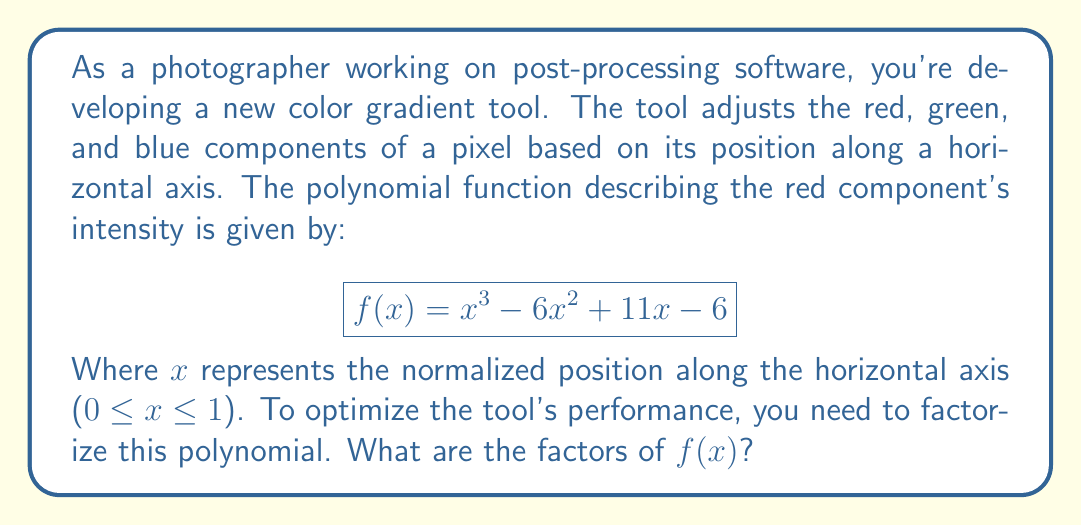Could you help me with this problem? To factorize the polynomial $f(x) = x^3 - 6x^2 + 11x - 6$, we'll follow these steps:

1) First, let's check if there are any rational roots using the rational root theorem. The possible rational roots are the factors of the constant term: ±1, ±2, ±3, ±6.

2) Testing these values, we find that $f(1) = 0$. So $(x-1)$ is a factor.

3) We can use polynomial long division to divide $f(x)$ by $(x-1)$:

   $$\frac{x^3 - 6x^2 + 11x - 6}{x-1} = x^2 - 5x + 6$$

4) Now we have: $f(x) = (x-1)(x^2 - 5x + 6)$

5) The quadratic factor $x^2 - 5x + 6$ can be factored further using the quadratic formula or by inspection. Its roots are 2 and 3.

6) Therefore, $x^2 - 5x + 6 = (x-2)(x-3)$

7) Combining all factors, we get:

   $$f(x) = (x-1)(x-2)(x-3)$$

This factorization shows that the red component's intensity reaches zero at three specific points along the horizontal axis: $x = 1$, $x = 2$, and $x = 3$. However, since our normalized position $x$ is between 0 and 1, only the root at $x = 1$ falls within the actual gradient range.
Answer: $f(x) = (x-1)(x-2)(x-3)$ 